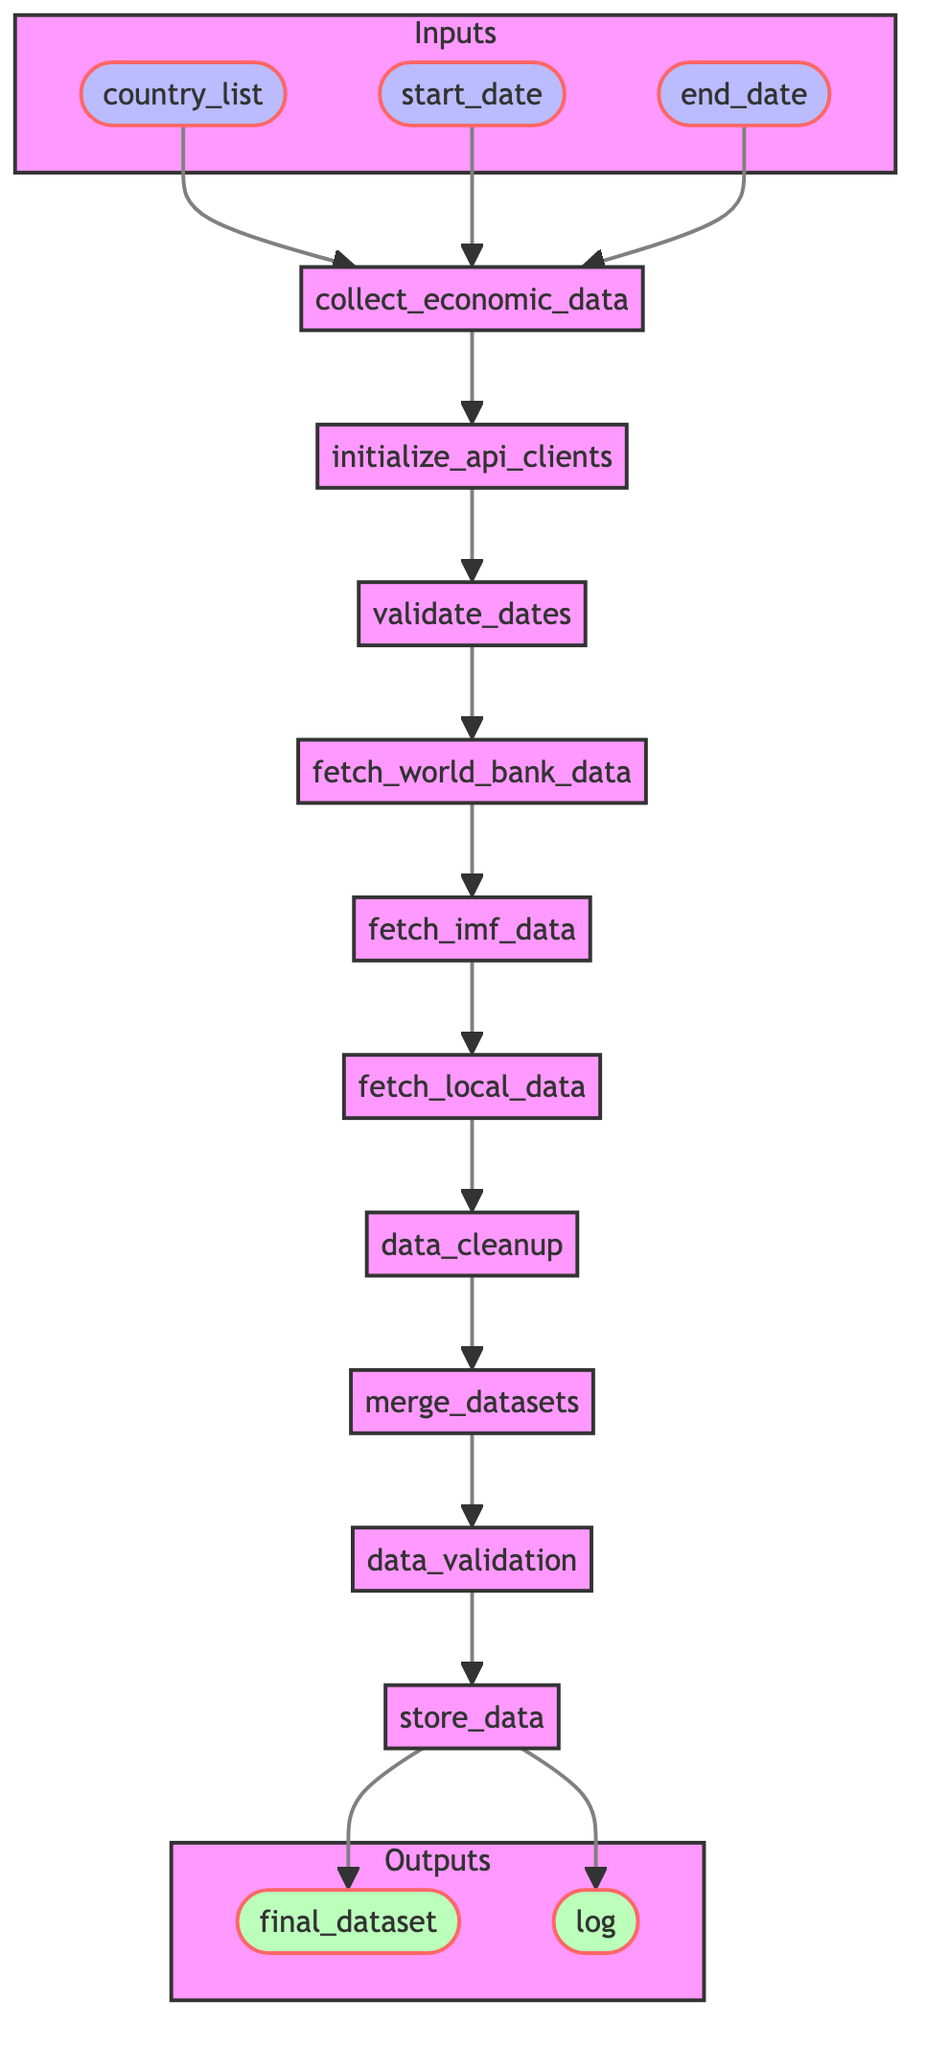What are the inputs to the function? The inputs to the function are displayed in the diagram as three nodes: country_list, start_date, and end_date.
Answer: country_list, start_date, end_date How many steps are there in the data collection process? The diagram shows a sequence from initialization to data storage. Counting all nodes from initialize_api_clients through to store_data gives a total of nine steps.
Answer: 9 What is the first step in the function? The diagram indicates that the first step, following the entry into the function, is initializing API clients.
Answer: initialize_api_clients Which step occurs after data cleanup? According to the flowchart, the step that follows data cleanup is merging datasets.
Answer: merge_datasets What is the last step of the process? The flowchart reveals that the last step in the data collection pipeline is storing the data.
Answer: store_data Which API clients are initialized in the initial step? The description states that API clients for World Bank, IMF, and local government databases are initialized in the first step.
Answer: World Bank, IMF, local government What is done after fetching IMF data? Based on the diagram, after fetching IMF data, the next step is fetching local data.
Answer: fetch_local_data What would happen if the date validation fails? The flowchart does not explicitly describe events for validation failure, but logically it would halt the process; however, it proceeds to fetch world bank data if valid.
Answer: (process halts) How is data accuracy ensured in the pipeline? The pipeline includes a specific step for data validation where checks for accuracy and completeness are performed.
Answer: data_validation What outputs are generated at the end of the function? The outputs noted at the end of the process in the flowchart are final_dataset and log.
Answer: final_dataset, log 